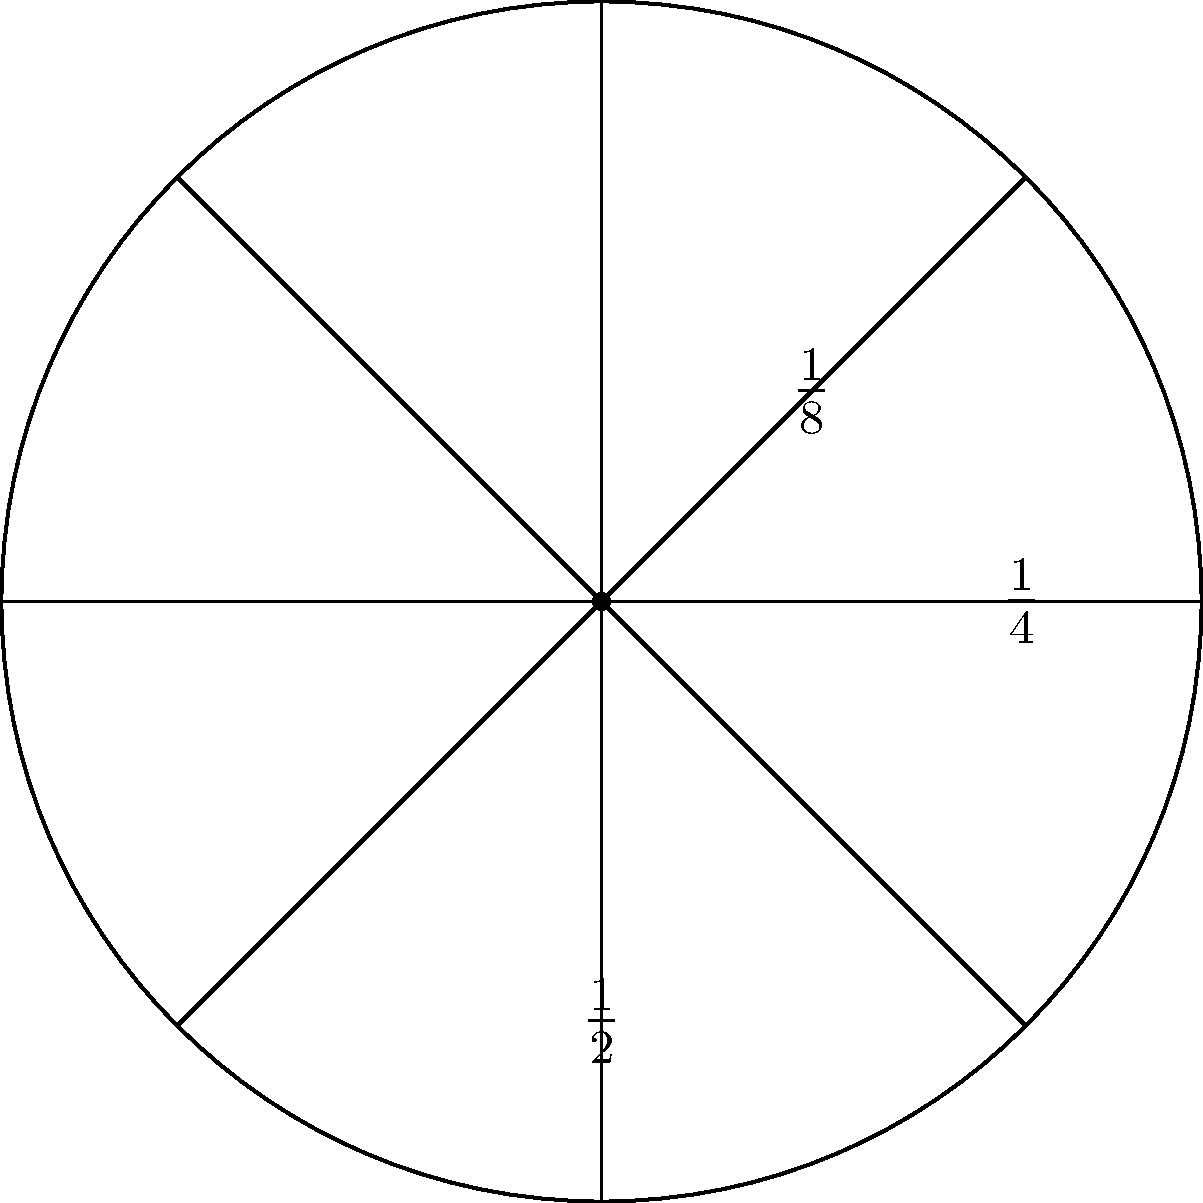Look at the circle divided into fractions. If the shaded part represents $\frac{1}{8}$ of the circle, what is its decimal equivalent? Let's solve this step-by-step:

1) We know that $\frac{1}{8}$ is a fraction.

2) To convert a fraction to a decimal, we divide the numerator by the denominator:
   $\frac{1}{8} = 1 \div 8$

3) Let's perform the division:
   $1 \div 8 = 0.125$

4) We can check this:
   $0.125 \times 8 = 1$

5) Therefore, $\frac{1}{8}$ is equal to $0.125$ in decimal form.
Answer: $0.125$ 